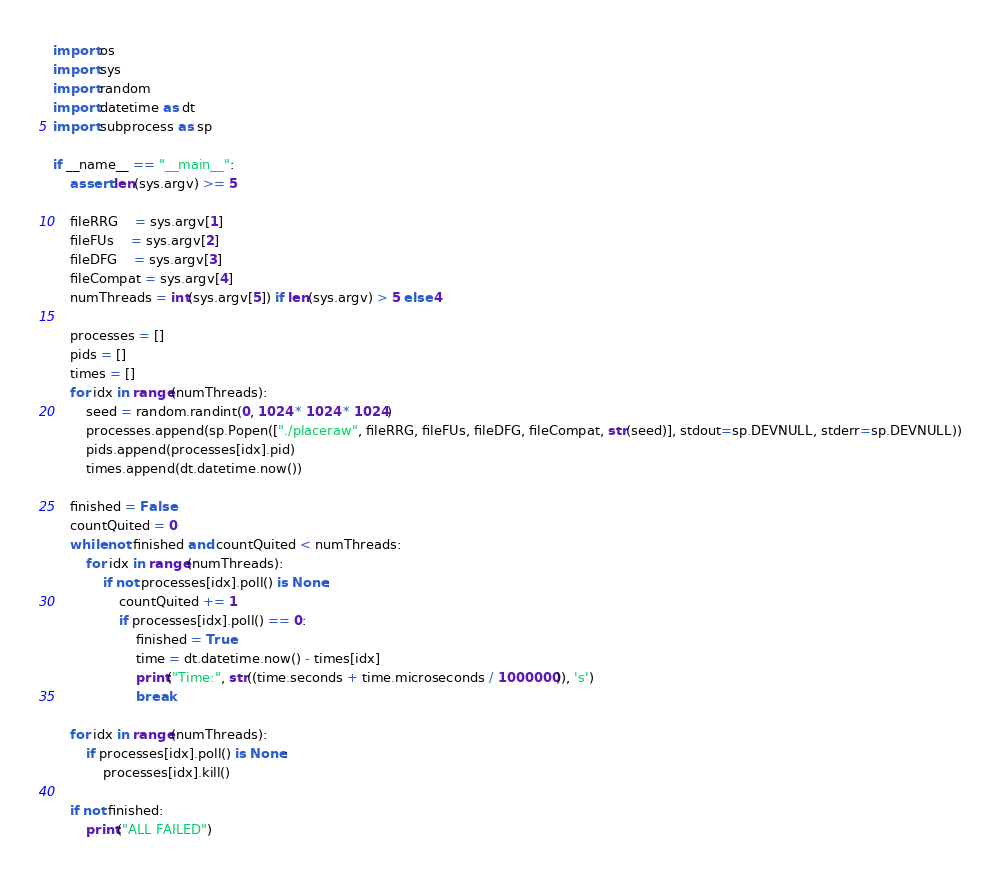Convert code to text. <code><loc_0><loc_0><loc_500><loc_500><_Python_>import os
import sys
import random
import datetime as dt
import subprocess as sp

if __name__ == "__main__": 
    assert len(sys.argv) >= 5

    fileRRG    = sys.argv[1]
    fileFUs    = sys.argv[2]
    fileDFG    = sys.argv[3]
    fileCompat = sys.argv[4]
    numThreads = int(sys.argv[5]) if len(sys.argv) > 5 else 4

    processes = []
    pids = []
    times = []
    for idx in range(numThreads):
        seed = random.randint(0, 1024 * 1024 * 1024)
        processes.append(sp.Popen(["./placeraw", fileRRG, fileFUs, fileDFG, fileCompat, str(seed)], stdout=sp.DEVNULL, stderr=sp.DEVNULL))
        pids.append(processes[idx].pid)
        times.append(dt.datetime.now())
    
    finished = False
    countQuited = 0
    while not finished and countQuited < numThreads: 
        for idx in range(numThreads):
            if not processes[idx].poll() is None: 
                countQuited += 1
                if processes[idx].poll() == 0: 
                    finished = True
                    time = dt.datetime.now() - times[idx]
                    print("Time:", str((time.seconds + time.microseconds / 1000000)), 's')
                    break
    
    for idx in range(numThreads):
        if processes[idx].poll() is None:  
            processes[idx].kill()

    if not finished: 
        print("ALL FAILED")



</code> 